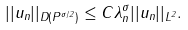<formula> <loc_0><loc_0><loc_500><loc_500>| | u _ { n } | | _ { D ( P ^ { \sigma / 2 } ) } \leq C \lambda _ { n } ^ { \sigma } | | u _ { n } | | _ { L ^ { 2 } } .</formula> 